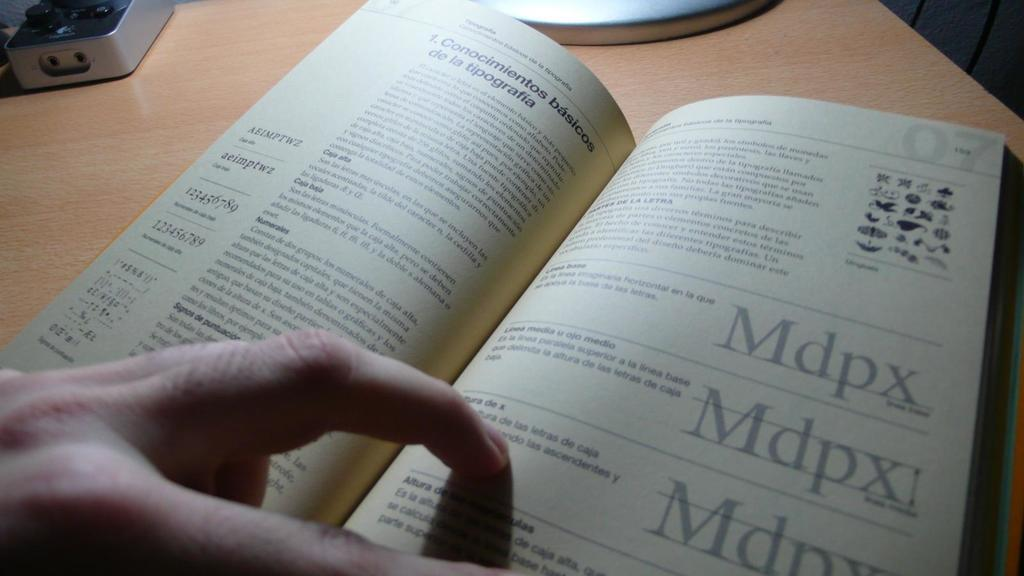<image>
Give a short and clear explanation of the subsequent image. A hand rests on the page of a book discussing Mdpx. 